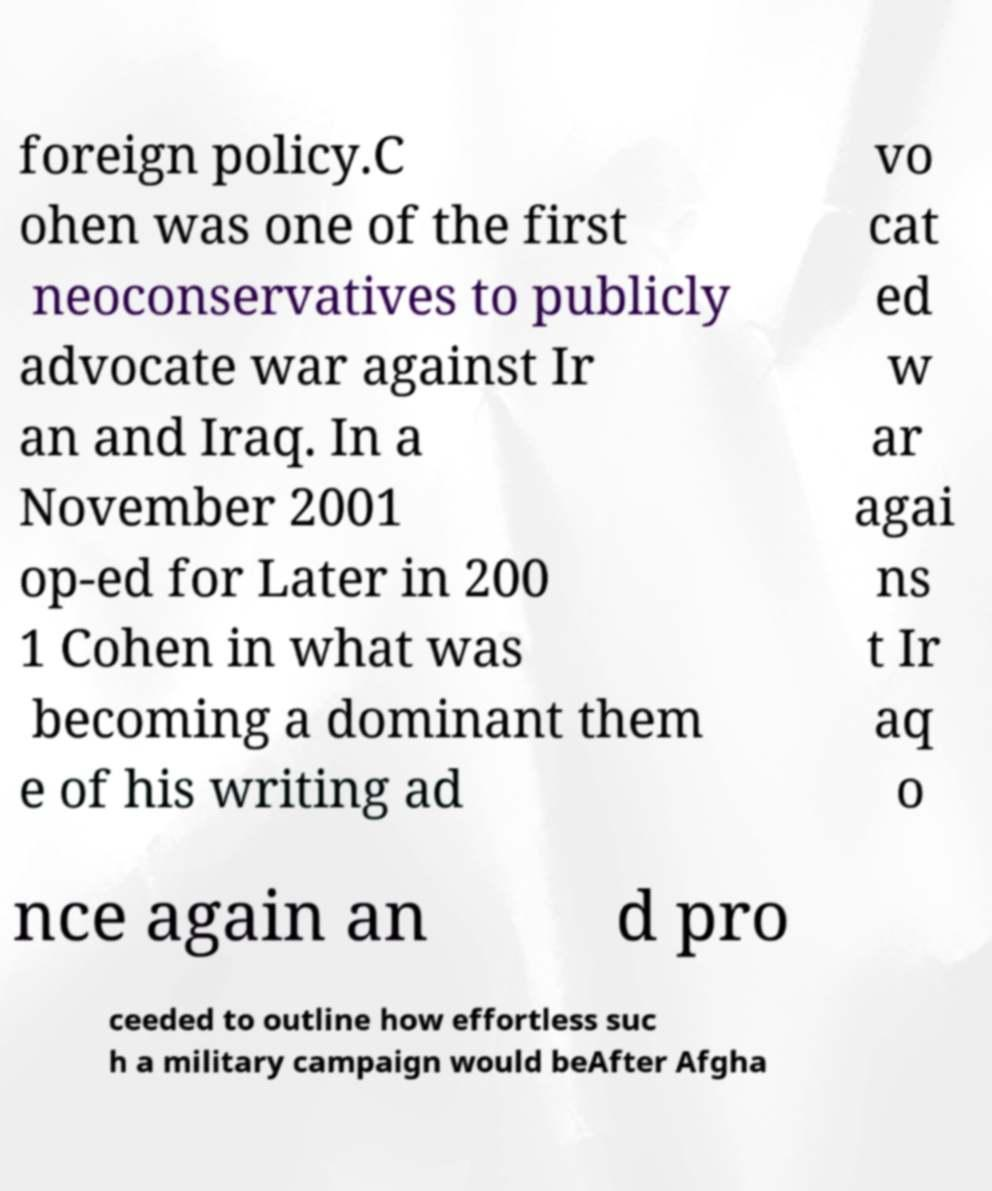Could you assist in decoding the text presented in this image and type it out clearly? foreign policy.C ohen was one of the first neoconservatives to publicly advocate war against Ir an and Iraq. In a November 2001 op-ed for Later in 200 1 Cohen in what was becoming a dominant them e of his writing ad vo cat ed w ar agai ns t Ir aq o nce again an d pro ceeded to outline how effortless suc h a military campaign would beAfter Afgha 